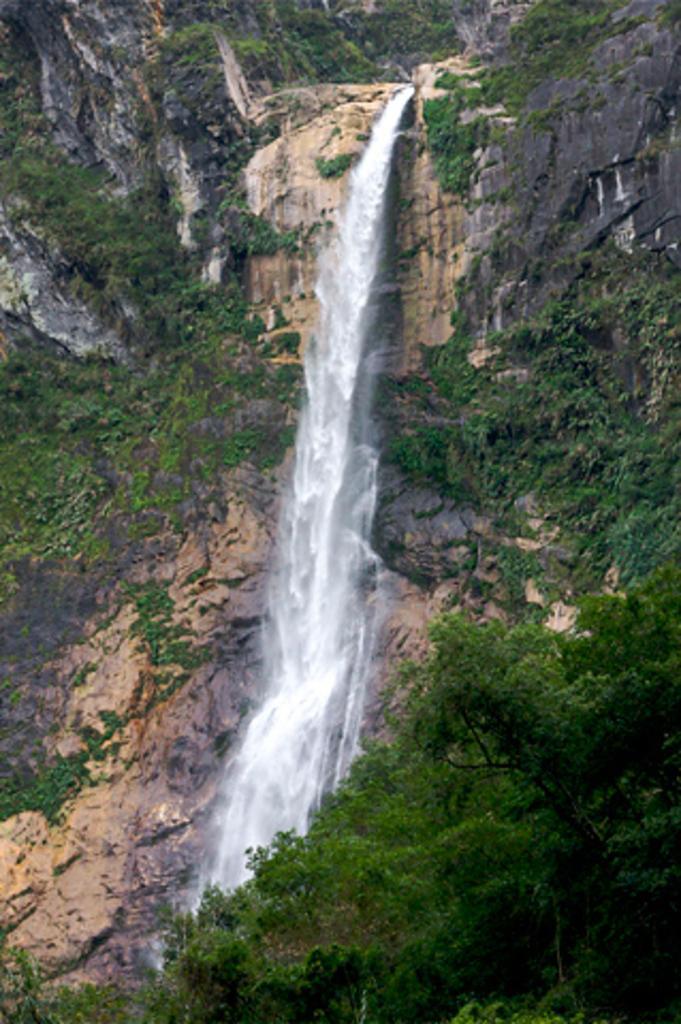In one or two sentences, can you explain what this image depicts? At the bottom of this image, there are plants and trees. In the background, there is a waterfall from a mountain on which there are trees. 